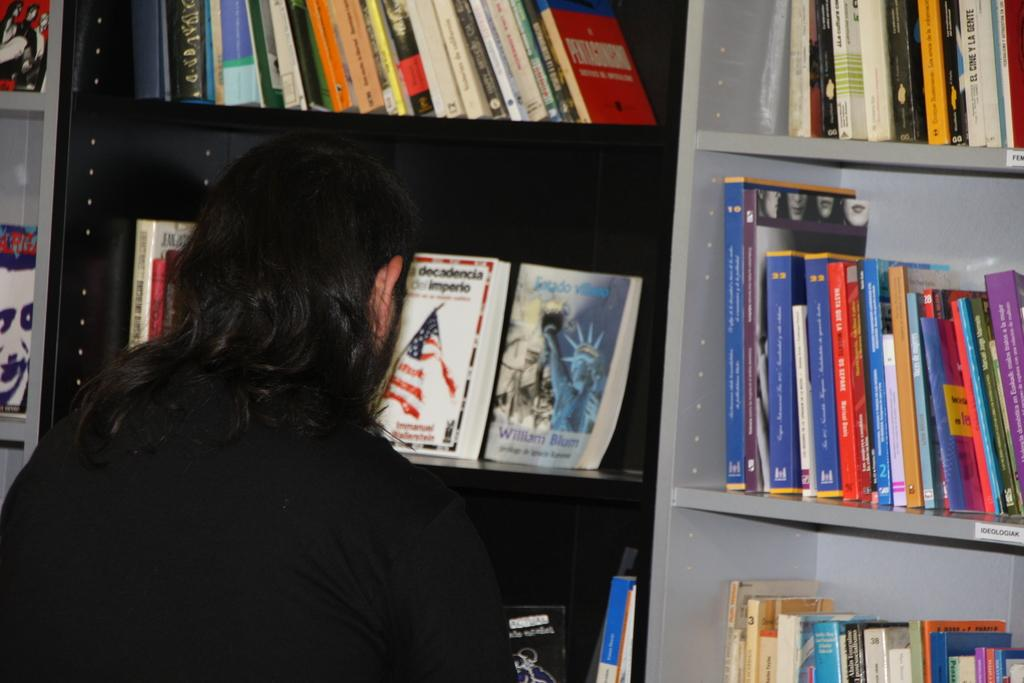Who or what is present in the image? There is a person in the image. What is the person wearing? The person is wearing clothes. What can be seen behind the person in the image? There are many books on a shelf in front of the person. What type of metal can be seen growing from the person's head in the image? There is no metal or any object growing from the person's head in the image. 